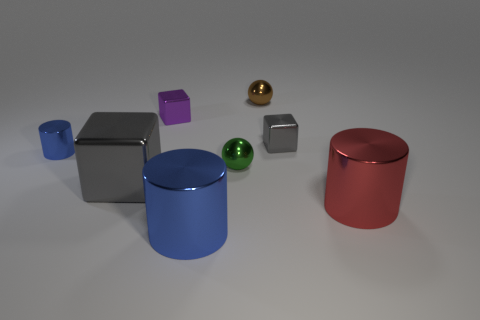There is a metal cylinder to the right of the small sphere left of the small brown object; how big is it?
Give a very brief answer. Large. How many blue things are either big shiny things or small rubber cubes?
Your answer should be compact. 1. Is the number of big red things that are behind the big red thing less than the number of small blue shiny objects in front of the tiny green ball?
Your answer should be very brief. No. There is a green thing; is its size the same as the cylinder behind the big red thing?
Provide a succinct answer. Yes. What number of other metal cubes are the same size as the purple block?
Your answer should be compact. 1. What number of big things are cubes or brown spheres?
Keep it short and to the point. 1. Are there any large gray metallic cubes?
Your answer should be compact. Yes. Is the number of large objects that are left of the red object greater than the number of purple objects that are in front of the small metallic cylinder?
Keep it short and to the point. Yes. There is a shiny ball that is behind the small cube that is left of the large blue metal cylinder; what is its color?
Your answer should be compact. Brown. Are there any metallic objects that have the same color as the tiny cylinder?
Ensure brevity in your answer.  Yes. 